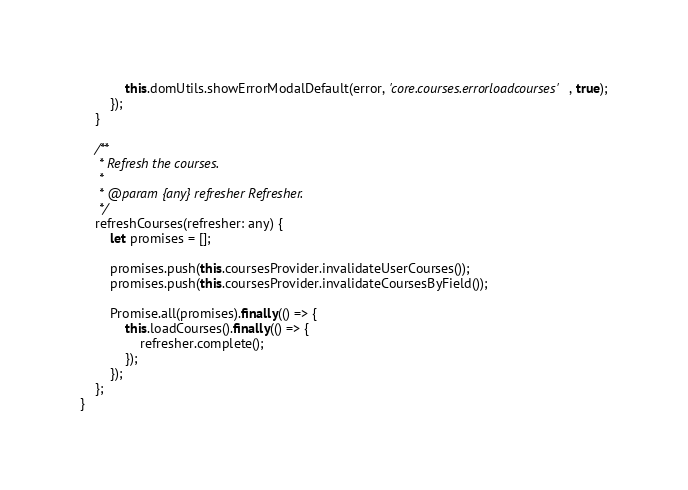<code> <loc_0><loc_0><loc_500><loc_500><_TypeScript_>            this.domUtils.showErrorModalDefault(error, 'core.courses.errorloadcourses', true);
        });
    }

    /**
     * Refresh the courses.
     *
     * @param {any} refresher Refresher.
     */
    refreshCourses(refresher: any) {
        let promises = [];

        promises.push(this.coursesProvider.invalidateUserCourses());
        promises.push(this.coursesProvider.invalidateCoursesByField());

        Promise.all(promises).finally(() => {
            this.loadCourses().finally(() => {
                refresher.complete();
            });
        });
    };
}
</code> 